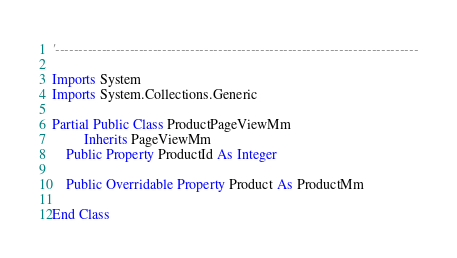<code> <loc_0><loc_0><loc_500><loc_500><_VisualBasic_>'------------------------------------------------------------------------------

Imports System
Imports System.Collections.Generic

Partial Public Class ProductPageViewMm
         Inherits PageViewMm
    Public Property ProductId As Integer

    Public Overridable Property Product As ProductMm

End Class
</code> 